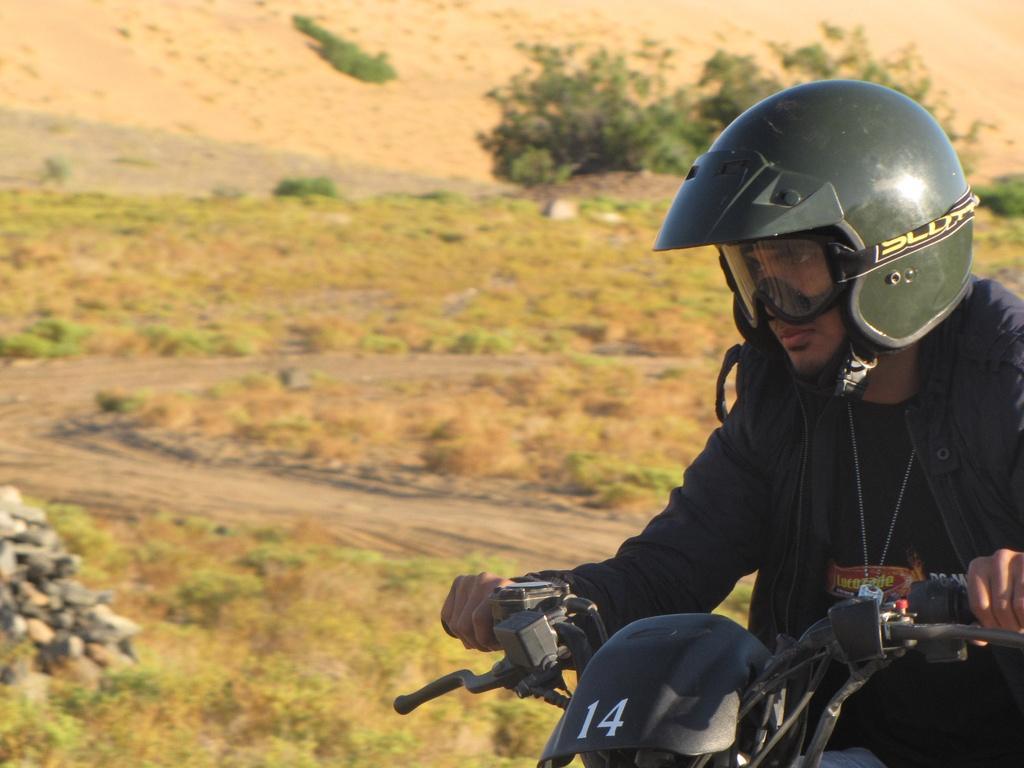In one or two sentences, can you explain what this image depicts? In the image we can see there is a person sitting on the bike and he is wearing helmet and jacket. Beside there is ground which is covered with grass and behind there are trees. 